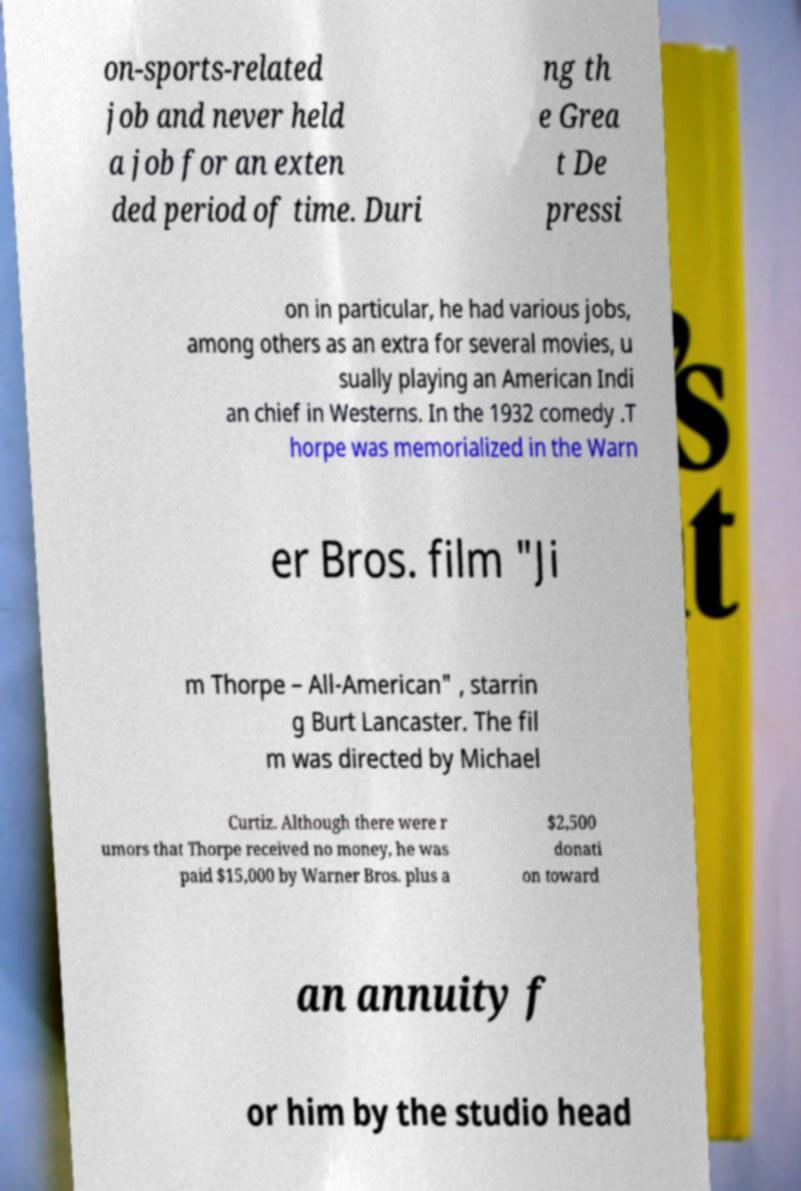Please read and relay the text visible in this image. What does it say? on-sports-related job and never held a job for an exten ded period of time. Duri ng th e Grea t De pressi on in particular, he had various jobs, among others as an extra for several movies, u sually playing an American Indi an chief in Westerns. In the 1932 comedy .T horpe was memorialized in the Warn er Bros. film "Ji m Thorpe – All-American" , starrin g Burt Lancaster. The fil m was directed by Michael Curtiz. Although there were r umors that Thorpe received no money, he was paid $15,000 by Warner Bros. plus a $2,500 donati on toward an annuity f or him by the studio head 